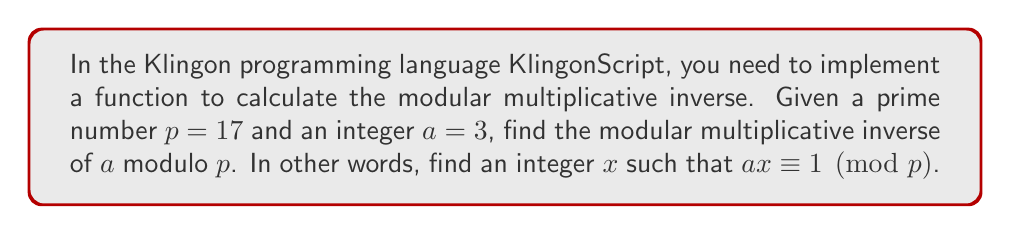Can you answer this question? To find the modular multiplicative inverse, we can use the extended Euclidean algorithm. This algorithm finds the greatest common divisor (GCD) of two numbers and expresses it as a linear combination of these numbers.

Step 1: Apply the extended Euclidean algorithm to $p$ and $a$:

$17 = 5 \cdot 3 + 2$
$3 = 1 \cdot 2 + 1$
$2 = 2 \cdot 1 + 0$

Step 2: Work backwards to express the GCD (which is 1) as a linear combination of $p$ and $a$:

$1 = 3 - 1 \cdot 2$
$1 = 3 - 1 \cdot (17 - 5 \cdot 3)$
$1 = 6 \cdot 3 - 1 \cdot 17$

Step 3: The coefficient of $3$ in this expression is $6$, which is the modular multiplicative inverse of $3$ modulo $17$. However, we need to ensure it's positive and less than $17$:

$6 \bmod 17 = 6$

Step 4: Verify the result:

$3 \cdot 6 \bmod 17 = 18 \bmod 17 = 1$

Therefore, the modular multiplicative inverse of $3$ modulo $17$ is $6$.
Answer: $6$ 